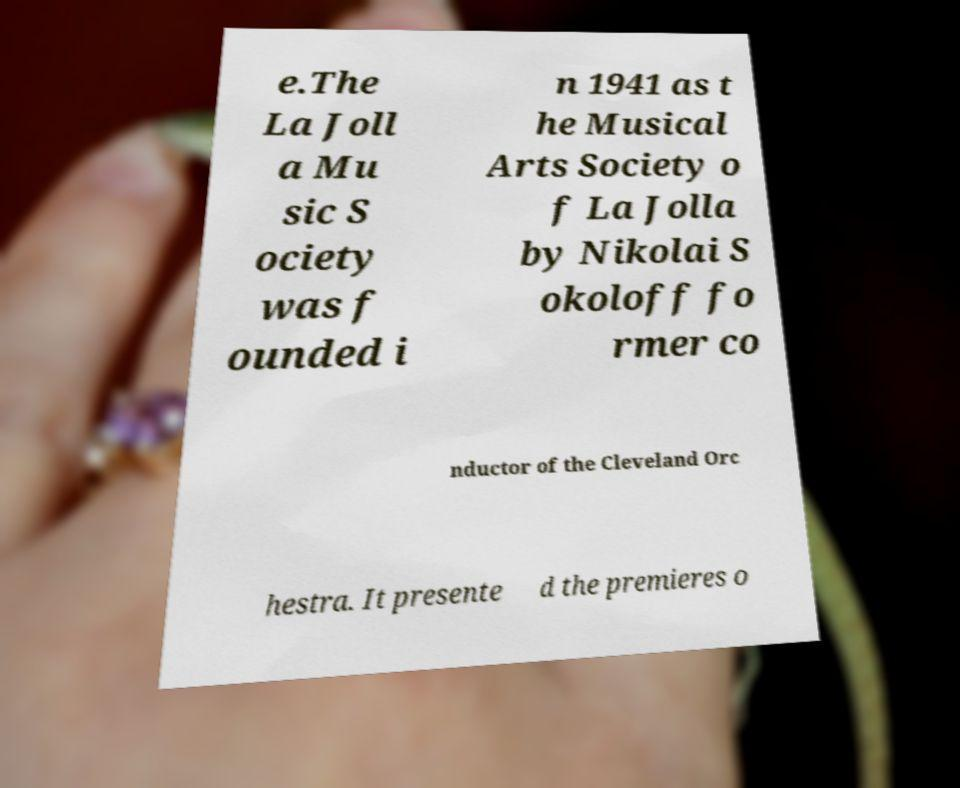There's text embedded in this image that I need extracted. Can you transcribe it verbatim? e.The La Joll a Mu sic S ociety was f ounded i n 1941 as t he Musical Arts Society o f La Jolla by Nikolai S okoloff fo rmer co nductor of the Cleveland Orc hestra. It presente d the premieres o 